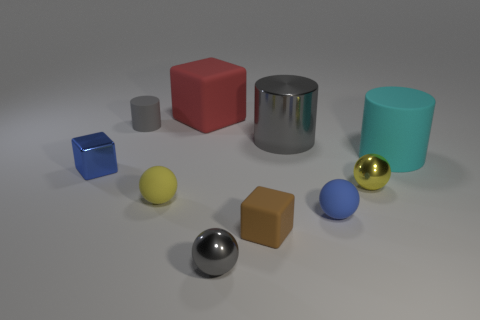How many small metallic spheres are the same color as the big shiny object?
Keep it short and to the point. 1. There is a metal object that is the same color as the metallic cylinder; what is its size?
Offer a very short reply. Small. There is a brown matte thing; is it the same shape as the large object left of the gray ball?
Your response must be concise. Yes. How many gray things are both on the right side of the large red rubber thing and left of the metal cylinder?
Ensure brevity in your answer.  1. There is a tiny brown thing that is the same shape as the big red thing; what is its material?
Give a very brief answer. Rubber. What size is the matte cylinder that is on the right side of the red block left of the brown cube?
Give a very brief answer. Large. Is there a tiny gray cylinder?
Offer a terse response. Yes. The tiny sphere that is behind the tiny blue ball and left of the blue ball is made of what material?
Make the answer very short. Rubber. Is the number of small cubes that are behind the yellow metal thing greater than the number of small yellow matte balls to the left of the small gray cylinder?
Make the answer very short. Yes. Are there any purple cubes of the same size as the cyan thing?
Provide a short and direct response. No. 